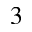Convert formula to latex. <formula><loc_0><loc_0><loc_500><loc_500>_ { 3 }</formula> 